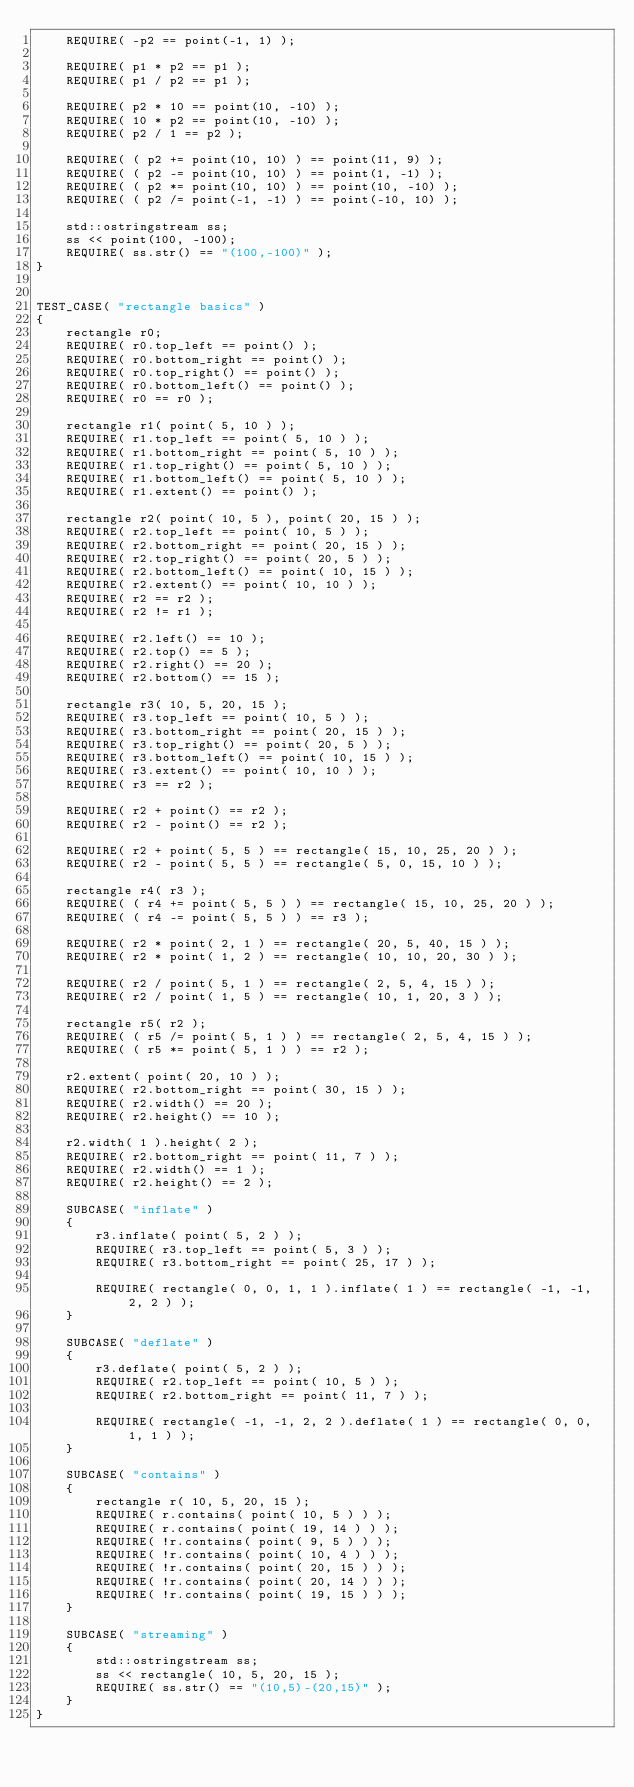<code> <loc_0><loc_0><loc_500><loc_500><_C++_>    REQUIRE( -p2 == point(-1, 1) );

    REQUIRE( p1 * p2 == p1 );
    REQUIRE( p1 / p2 == p1 );

    REQUIRE( p2 * 10 == point(10, -10) );
    REQUIRE( 10 * p2 == point(10, -10) );
    REQUIRE( p2 / 1 == p2 );

    REQUIRE( ( p2 += point(10, 10) ) == point(11, 9) );
    REQUIRE( ( p2 -= point(10, 10) ) == point(1, -1) );
    REQUIRE( ( p2 *= point(10, 10) ) == point(10, -10) );
    REQUIRE( ( p2 /= point(-1, -1) ) == point(-10, 10) );

    std::ostringstream ss;
    ss << point(100, -100);
    REQUIRE( ss.str() == "(100,-100)" );    
}


TEST_CASE( "rectangle basics" ) 
{
    rectangle r0;
    REQUIRE( r0.top_left == point() );
    REQUIRE( r0.bottom_right == point() );
    REQUIRE( r0.top_right() == point() );
    REQUIRE( r0.bottom_left() == point() );
    REQUIRE( r0 == r0 );

    rectangle r1( point( 5, 10 ) );
    REQUIRE( r1.top_left == point( 5, 10 ) );
    REQUIRE( r1.bottom_right == point( 5, 10 ) );
    REQUIRE( r1.top_right() == point( 5, 10 ) );
    REQUIRE( r1.bottom_left() == point( 5, 10 ) );
    REQUIRE( r1.extent() == point() );

    rectangle r2( point( 10, 5 ), point( 20, 15 ) );
    REQUIRE( r2.top_left == point( 10, 5 ) );
    REQUIRE( r2.bottom_right == point( 20, 15 ) );
    REQUIRE( r2.top_right() == point( 20, 5 ) );
    REQUIRE( r2.bottom_left() == point( 10, 15 ) );
    REQUIRE( r2.extent() == point( 10, 10 ) );
    REQUIRE( r2 == r2 );
    REQUIRE( r2 != r1 );

    REQUIRE( r2.left() == 10 );
    REQUIRE( r2.top() == 5 );
    REQUIRE( r2.right() == 20 );
    REQUIRE( r2.bottom() == 15 );

    rectangle r3( 10, 5, 20, 15 );
    REQUIRE( r3.top_left == point( 10, 5 ) );
    REQUIRE( r3.bottom_right == point( 20, 15 ) );
    REQUIRE( r3.top_right() == point( 20, 5 ) );
    REQUIRE( r3.bottom_left() == point( 10, 15 ) );
    REQUIRE( r3.extent() == point( 10, 10 ) );
    REQUIRE( r3 == r2 );

    REQUIRE( r2 + point() == r2 );
    REQUIRE( r2 - point() == r2 );

    REQUIRE( r2 + point( 5, 5 ) == rectangle( 15, 10, 25, 20 ) );
    REQUIRE( r2 - point( 5, 5 ) == rectangle( 5, 0, 15, 10 ) );

    rectangle r4( r3 );
    REQUIRE( ( r4 += point( 5, 5 ) ) == rectangle( 15, 10, 25, 20 ) );
    REQUIRE( ( r4 -= point( 5, 5 ) ) == r3 );

    REQUIRE( r2 * point( 2, 1 ) == rectangle( 20, 5, 40, 15 ) );
    REQUIRE( r2 * point( 1, 2 ) == rectangle( 10, 10, 20, 30 ) );

    REQUIRE( r2 / point( 5, 1 ) == rectangle( 2, 5, 4, 15 ) );
    REQUIRE( r2 / point( 1, 5 ) == rectangle( 10, 1, 20, 3 ) );

    rectangle r5( r2 );
    REQUIRE( ( r5 /= point( 5, 1 ) ) == rectangle( 2, 5, 4, 15 ) );
    REQUIRE( ( r5 *= point( 5, 1 ) ) == r2 );

    r2.extent( point( 20, 10 ) );
    REQUIRE( r2.bottom_right == point( 30, 15 ) );
    REQUIRE( r2.width() == 20 );
    REQUIRE( r2.height() == 10 );
    
    r2.width( 1 ).height( 2 );
    REQUIRE( r2.bottom_right == point( 11, 7 ) );
    REQUIRE( r2.width() == 1 );
    REQUIRE( r2.height() == 2 );

    SUBCASE( "inflate" )
    {
        r3.inflate( point( 5, 2 ) );
        REQUIRE( r3.top_left == point( 5, 3 ) );
        REQUIRE( r3.bottom_right == point( 25, 17 ) );

        REQUIRE( rectangle( 0, 0, 1, 1 ).inflate( 1 ) == rectangle( -1, -1, 2, 2 ) );
    }

    SUBCASE( "deflate" )
    {
        r3.deflate( point( 5, 2 ) );
        REQUIRE( r2.top_left == point( 10, 5 ) );
        REQUIRE( r2.bottom_right == point( 11, 7 ) );

        REQUIRE( rectangle( -1, -1, 2, 2 ).deflate( 1 ) == rectangle( 0, 0, 1, 1 ) );
    }

    SUBCASE( "contains" )
    {
        rectangle r( 10, 5, 20, 15 );
        REQUIRE( r.contains( point( 10, 5 ) ) );
        REQUIRE( r.contains( point( 19, 14 ) ) );
        REQUIRE( !r.contains( point( 9, 5 ) ) );
        REQUIRE( !r.contains( point( 10, 4 ) ) );
        REQUIRE( !r.contains( point( 20, 15 ) ) );
        REQUIRE( !r.contains( point( 20, 14 ) ) );
        REQUIRE( !r.contains( point( 19, 15 ) ) );
    }

    SUBCASE( "streaming" )
    {
        std::ostringstream ss;
        ss << rectangle( 10, 5, 20, 15 );
        REQUIRE( ss.str() == "(10,5)-(20,15)" );
    }
}
</code> 